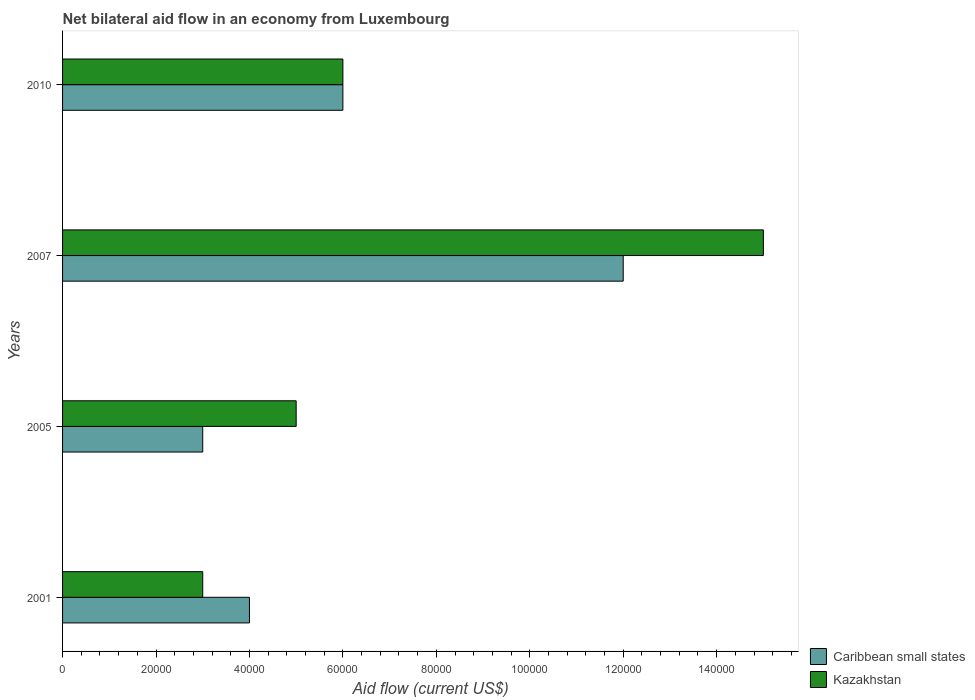How many different coloured bars are there?
Offer a terse response. 2. How many groups of bars are there?
Give a very brief answer. 4. Are the number of bars per tick equal to the number of legend labels?
Your answer should be compact. Yes. What is the label of the 2nd group of bars from the top?
Give a very brief answer. 2007. Across all years, what is the minimum net bilateral aid flow in Caribbean small states?
Your answer should be compact. 3.00e+04. In which year was the net bilateral aid flow in Kazakhstan maximum?
Your answer should be compact. 2007. What is the difference between the net bilateral aid flow in Caribbean small states in 2001 and that in 2005?
Provide a succinct answer. 10000. What is the difference between the net bilateral aid flow in Caribbean small states in 2010 and the net bilateral aid flow in Kazakhstan in 2001?
Ensure brevity in your answer.  3.00e+04. What is the average net bilateral aid flow in Caribbean small states per year?
Provide a succinct answer. 6.25e+04. In how many years, is the net bilateral aid flow in Kazakhstan greater than 112000 US$?
Your response must be concise. 1. What is the ratio of the net bilateral aid flow in Caribbean small states in 2007 to that in 2010?
Provide a succinct answer. 2. Is the net bilateral aid flow in Caribbean small states in 2001 less than that in 2010?
Provide a short and direct response. Yes. What is the difference between the highest and the second highest net bilateral aid flow in Caribbean small states?
Your answer should be compact. 6.00e+04. What is the difference between the highest and the lowest net bilateral aid flow in Caribbean small states?
Provide a succinct answer. 9.00e+04. In how many years, is the net bilateral aid flow in Caribbean small states greater than the average net bilateral aid flow in Caribbean small states taken over all years?
Ensure brevity in your answer.  1. What does the 1st bar from the top in 2007 represents?
Your response must be concise. Kazakhstan. What does the 1st bar from the bottom in 2005 represents?
Offer a terse response. Caribbean small states. What is the difference between two consecutive major ticks on the X-axis?
Keep it short and to the point. 2.00e+04. How are the legend labels stacked?
Give a very brief answer. Vertical. What is the title of the graph?
Offer a terse response. Net bilateral aid flow in an economy from Luxembourg. Does "Sao Tome and Principe" appear as one of the legend labels in the graph?
Give a very brief answer. No. What is the Aid flow (current US$) of Caribbean small states in 2001?
Provide a short and direct response. 4.00e+04. What is the Aid flow (current US$) of Kazakhstan in 2001?
Make the answer very short. 3.00e+04. What is the Aid flow (current US$) of Caribbean small states in 2010?
Offer a very short reply. 6.00e+04. Across all years, what is the maximum Aid flow (current US$) in Kazakhstan?
Your answer should be very brief. 1.50e+05. What is the total Aid flow (current US$) of Caribbean small states in the graph?
Provide a succinct answer. 2.50e+05. What is the total Aid flow (current US$) of Kazakhstan in the graph?
Your response must be concise. 2.90e+05. What is the difference between the Aid flow (current US$) of Caribbean small states in 2001 and that in 2005?
Offer a very short reply. 10000. What is the difference between the Aid flow (current US$) of Kazakhstan in 2001 and that in 2005?
Your answer should be very brief. -2.00e+04. What is the difference between the Aid flow (current US$) in Caribbean small states in 2001 and that in 2007?
Keep it short and to the point. -8.00e+04. What is the difference between the Aid flow (current US$) of Caribbean small states in 2001 and that in 2010?
Give a very brief answer. -2.00e+04. What is the difference between the Aid flow (current US$) in Caribbean small states in 2005 and that in 2007?
Give a very brief answer. -9.00e+04. What is the difference between the Aid flow (current US$) of Kazakhstan in 2005 and that in 2007?
Provide a succinct answer. -1.00e+05. What is the difference between the Aid flow (current US$) of Caribbean small states in 2005 and that in 2010?
Give a very brief answer. -3.00e+04. What is the difference between the Aid flow (current US$) in Caribbean small states in 2007 and that in 2010?
Ensure brevity in your answer.  6.00e+04. What is the difference between the Aid flow (current US$) in Caribbean small states in 2001 and the Aid flow (current US$) in Kazakhstan in 2007?
Your answer should be very brief. -1.10e+05. What is the difference between the Aid flow (current US$) of Caribbean small states in 2001 and the Aid flow (current US$) of Kazakhstan in 2010?
Ensure brevity in your answer.  -2.00e+04. What is the difference between the Aid flow (current US$) of Caribbean small states in 2005 and the Aid flow (current US$) of Kazakhstan in 2010?
Your response must be concise. -3.00e+04. What is the difference between the Aid flow (current US$) in Caribbean small states in 2007 and the Aid flow (current US$) in Kazakhstan in 2010?
Offer a terse response. 6.00e+04. What is the average Aid flow (current US$) of Caribbean small states per year?
Make the answer very short. 6.25e+04. What is the average Aid flow (current US$) in Kazakhstan per year?
Your response must be concise. 7.25e+04. In the year 2001, what is the difference between the Aid flow (current US$) in Caribbean small states and Aid flow (current US$) in Kazakhstan?
Your answer should be very brief. 10000. In the year 2007, what is the difference between the Aid flow (current US$) of Caribbean small states and Aid flow (current US$) of Kazakhstan?
Your answer should be compact. -3.00e+04. What is the ratio of the Aid flow (current US$) of Caribbean small states in 2001 to that in 2005?
Offer a terse response. 1.33. What is the ratio of the Aid flow (current US$) in Caribbean small states in 2005 to that in 2007?
Your answer should be very brief. 0.25. What is the ratio of the Aid flow (current US$) in Kazakhstan in 2005 to that in 2007?
Provide a short and direct response. 0.33. What is the ratio of the Aid flow (current US$) of Caribbean small states in 2005 to that in 2010?
Your answer should be compact. 0.5. What is the ratio of the Aid flow (current US$) in Kazakhstan in 2005 to that in 2010?
Make the answer very short. 0.83. What is the difference between the highest and the second highest Aid flow (current US$) of Kazakhstan?
Offer a very short reply. 9.00e+04. What is the difference between the highest and the lowest Aid flow (current US$) of Kazakhstan?
Give a very brief answer. 1.20e+05. 